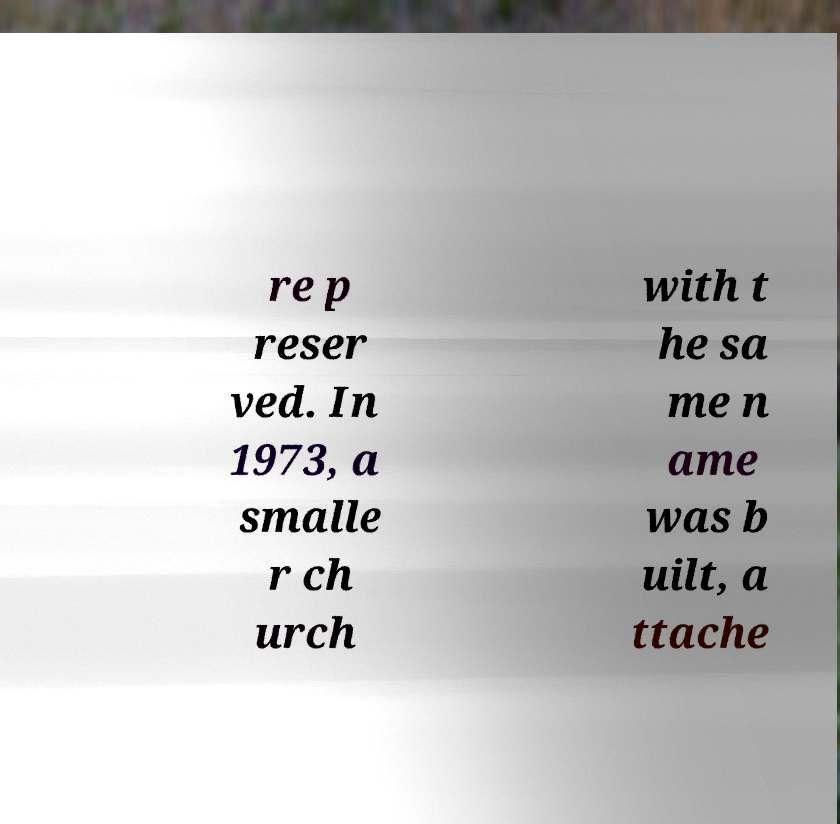Please identify and transcribe the text found in this image. re p reser ved. In 1973, a smalle r ch urch with t he sa me n ame was b uilt, a ttache 